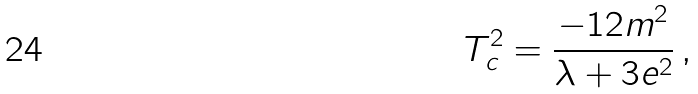<formula> <loc_0><loc_0><loc_500><loc_500>T _ { c } ^ { 2 } = \frac { - 1 2 m ^ { 2 } } { \lambda + 3 e ^ { 2 } } \, ,</formula> 